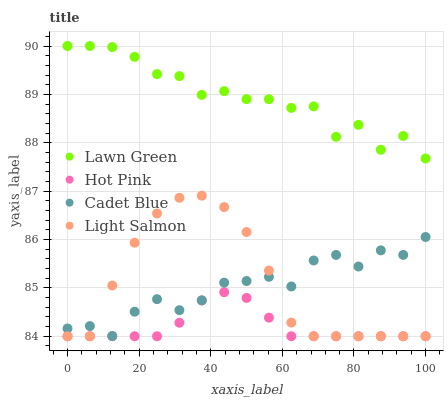Does Hot Pink have the minimum area under the curve?
Answer yes or no. Yes. Does Lawn Green have the maximum area under the curve?
Answer yes or no. Yes. Does Light Salmon have the minimum area under the curve?
Answer yes or no. No. Does Light Salmon have the maximum area under the curve?
Answer yes or no. No. Is Hot Pink the smoothest?
Answer yes or no. Yes. Is Lawn Green the roughest?
Answer yes or no. Yes. Is Light Salmon the smoothest?
Answer yes or no. No. Is Light Salmon the roughest?
Answer yes or no. No. Does Light Salmon have the lowest value?
Answer yes or no. Yes. Does Lawn Green have the lowest value?
Answer yes or no. No. Does Lawn Green have the highest value?
Answer yes or no. Yes. Does Light Salmon have the highest value?
Answer yes or no. No. Is Cadet Blue less than Lawn Green?
Answer yes or no. Yes. Is Cadet Blue greater than Hot Pink?
Answer yes or no. Yes. Does Light Salmon intersect Hot Pink?
Answer yes or no. Yes. Is Light Salmon less than Hot Pink?
Answer yes or no. No. Is Light Salmon greater than Hot Pink?
Answer yes or no. No. Does Cadet Blue intersect Lawn Green?
Answer yes or no. No. 